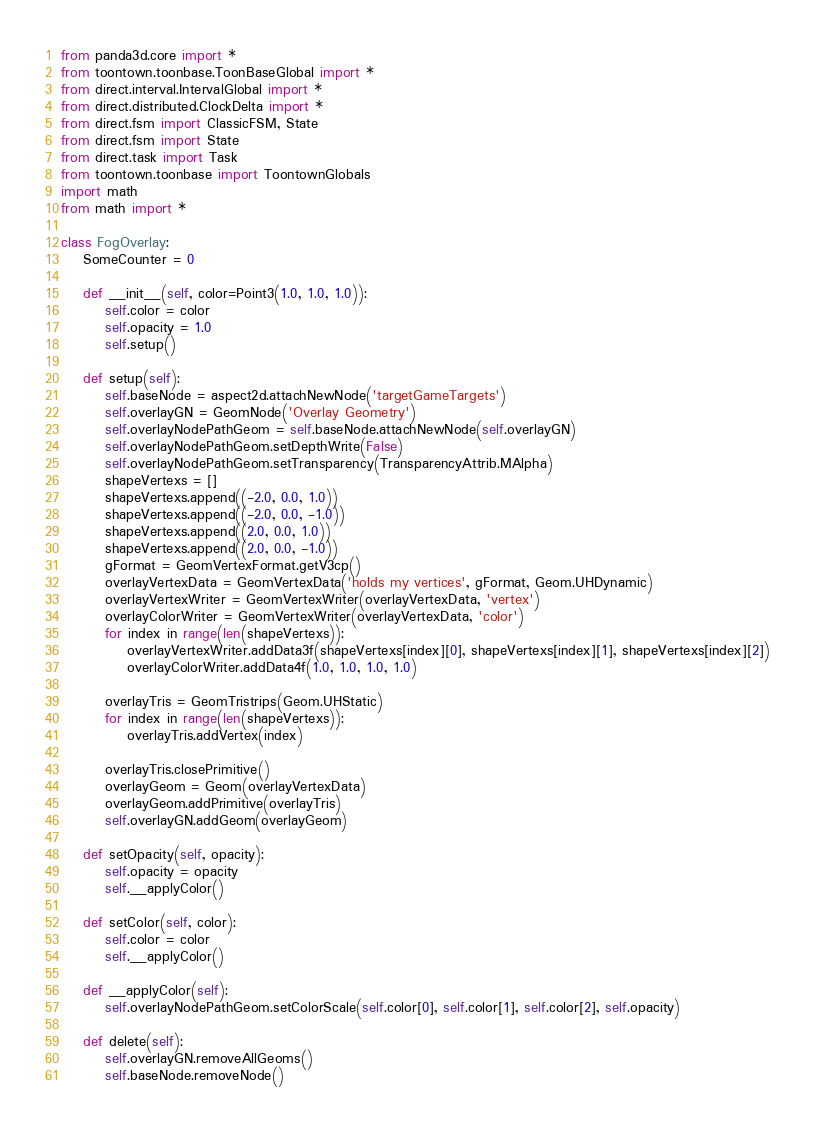Convert code to text. <code><loc_0><loc_0><loc_500><loc_500><_Python_>from panda3d.core import *
from toontown.toonbase.ToonBaseGlobal import *
from direct.interval.IntervalGlobal import *
from direct.distributed.ClockDelta import *
from direct.fsm import ClassicFSM, State
from direct.fsm import State
from direct.task import Task
from toontown.toonbase import ToontownGlobals
import math
from math import *

class FogOverlay:
    SomeCounter = 0

    def __init__(self, color=Point3(1.0, 1.0, 1.0)):
        self.color = color
        self.opacity = 1.0
        self.setup()

    def setup(self):
        self.baseNode = aspect2d.attachNewNode('targetGameTargets')
        self.overlayGN = GeomNode('Overlay Geometry')
        self.overlayNodePathGeom = self.baseNode.attachNewNode(self.overlayGN)
        self.overlayNodePathGeom.setDepthWrite(False)
        self.overlayNodePathGeom.setTransparency(TransparencyAttrib.MAlpha)
        shapeVertexs = []
        shapeVertexs.append((-2.0, 0.0, 1.0))
        shapeVertexs.append((-2.0, 0.0, -1.0))
        shapeVertexs.append((2.0, 0.0, 1.0))
        shapeVertexs.append((2.0, 0.0, -1.0))
        gFormat = GeomVertexFormat.getV3cp()
        overlayVertexData = GeomVertexData('holds my vertices', gFormat, Geom.UHDynamic)
        overlayVertexWriter = GeomVertexWriter(overlayVertexData, 'vertex')
        overlayColorWriter = GeomVertexWriter(overlayVertexData, 'color')
        for index in range(len(shapeVertexs)):
            overlayVertexWriter.addData3f(shapeVertexs[index][0], shapeVertexs[index][1], shapeVertexs[index][2])
            overlayColorWriter.addData4f(1.0, 1.0, 1.0, 1.0)

        overlayTris = GeomTristrips(Geom.UHStatic)
        for index in range(len(shapeVertexs)):
            overlayTris.addVertex(index)

        overlayTris.closePrimitive()
        overlayGeom = Geom(overlayVertexData)
        overlayGeom.addPrimitive(overlayTris)
        self.overlayGN.addGeom(overlayGeom)

    def setOpacity(self, opacity):
        self.opacity = opacity
        self.__applyColor()

    def setColor(self, color):
        self.color = color
        self.__applyColor()

    def __applyColor(self):
        self.overlayNodePathGeom.setColorScale(self.color[0], self.color[1], self.color[2], self.opacity)

    def delete(self):
        self.overlayGN.removeAllGeoms()
        self.baseNode.removeNode()</code> 